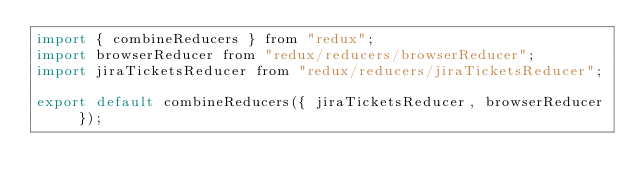Convert code to text. <code><loc_0><loc_0><loc_500><loc_500><_JavaScript_>import { combineReducers } from "redux";
import browserReducer from "redux/reducers/browserReducer";
import jiraTicketsReducer from "redux/reducers/jiraTicketsReducer";

export default combineReducers({ jiraTicketsReducer, browserReducer });</code> 